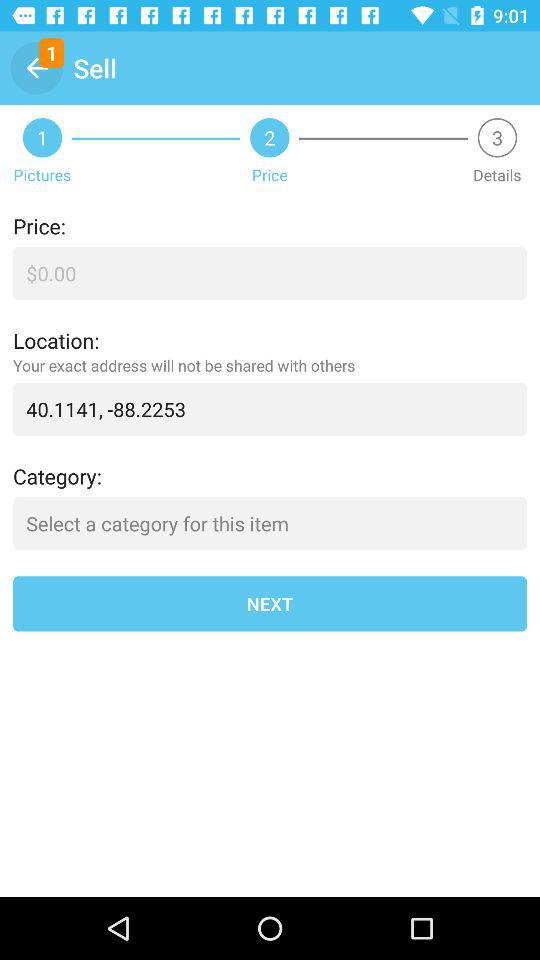Which step am I currently on? You are currently on step 2. 